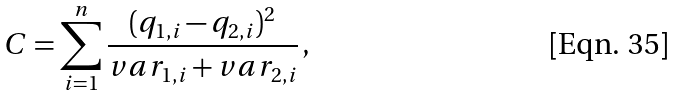<formula> <loc_0><loc_0><loc_500><loc_500>C = \sum _ { i = 1 } ^ { n } \frac { ( q _ { 1 , i } - q _ { 2 , i } ) ^ { 2 } } { v a r _ { 1 , i } + v a r _ { 2 , i } } \, ,</formula> 